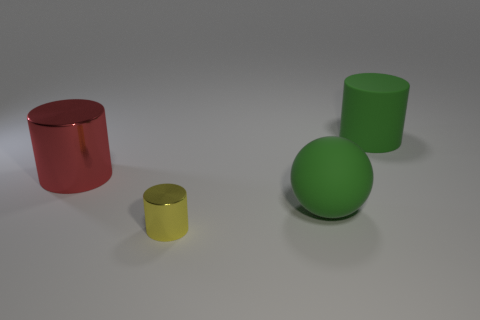Subtract all yellow cylinders. How many cylinders are left? 2 Add 2 large metallic cylinders. How many objects exist? 6 Subtract all yellow cylinders. How many cylinders are left? 2 Subtract 0 cyan blocks. How many objects are left? 4 Subtract all balls. How many objects are left? 3 Subtract all blue cylinders. Subtract all red spheres. How many cylinders are left? 3 Subtract all balls. Subtract all tiny gray rubber balls. How many objects are left? 3 Add 4 shiny objects. How many shiny objects are left? 6 Add 4 small objects. How many small objects exist? 5 